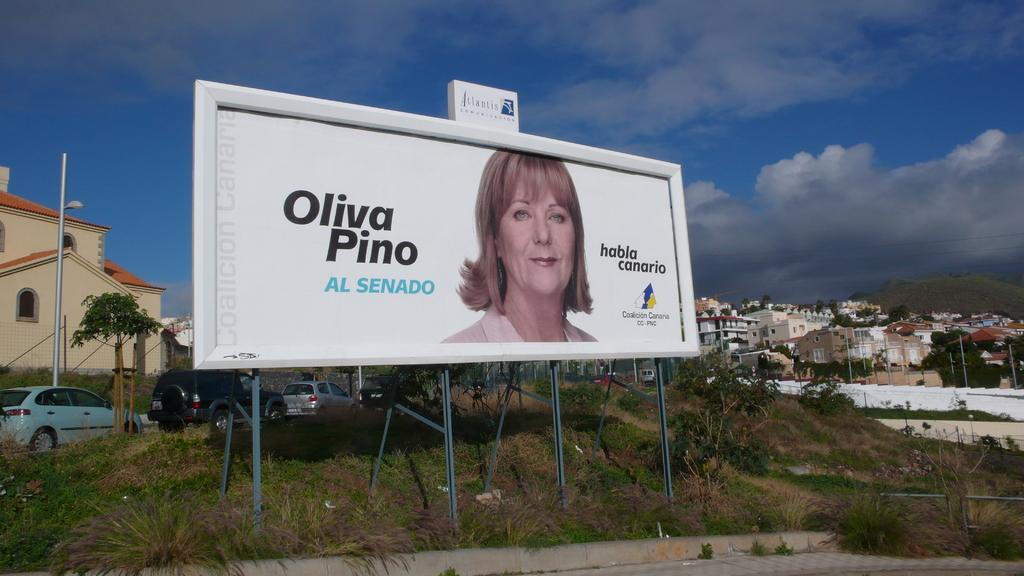Provide a one-sentence caption for the provided image. A billboard featuring a picture of a woman with the words Oliva Pino sitting in a run down suburb. 